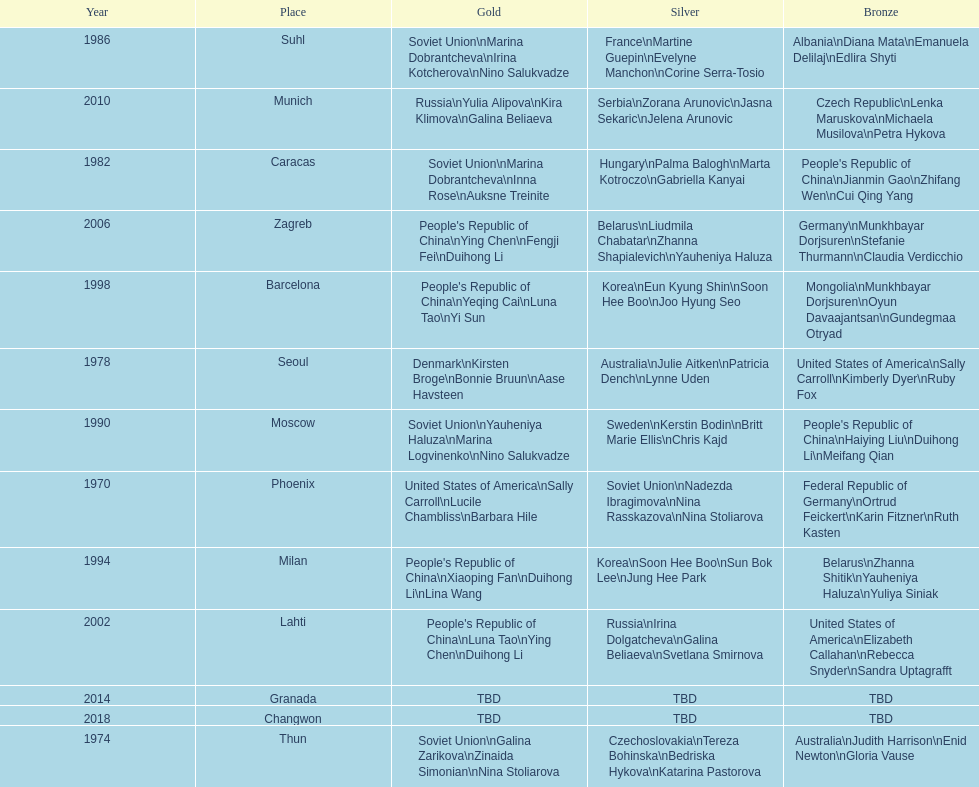Which country is listed the most under the silver column? Korea. 